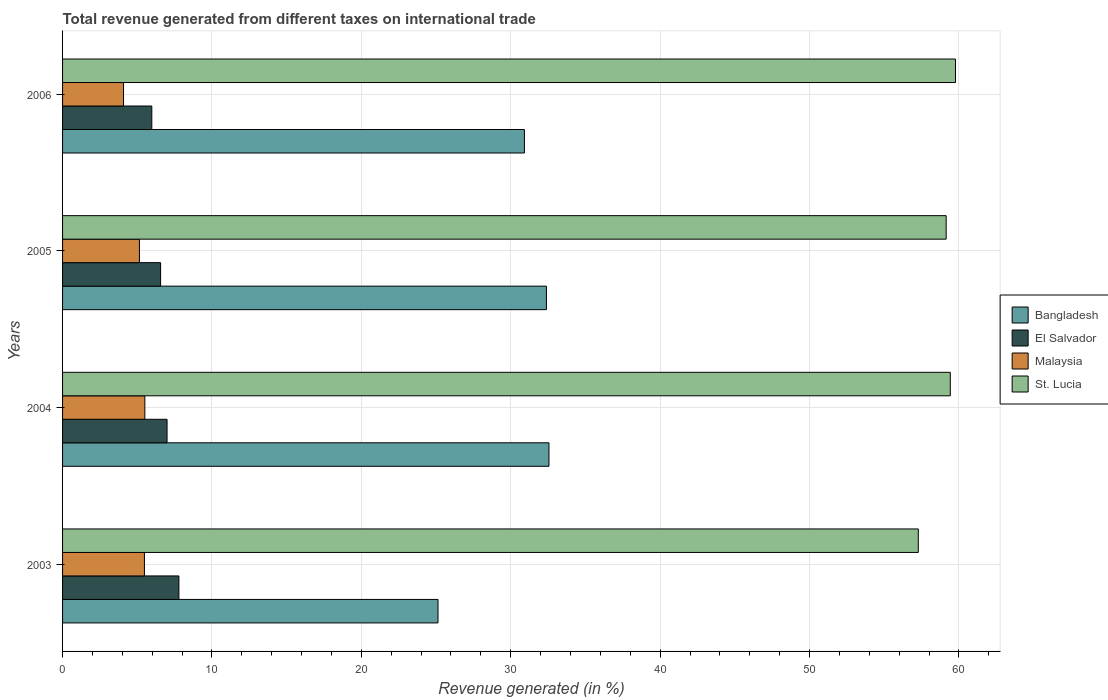How many different coloured bars are there?
Keep it short and to the point. 4. Are the number of bars per tick equal to the number of legend labels?
Offer a terse response. Yes. How many bars are there on the 2nd tick from the bottom?
Keep it short and to the point. 4. What is the label of the 2nd group of bars from the top?
Provide a succinct answer. 2005. What is the total revenue generated in El Salvador in 2005?
Offer a very short reply. 6.56. Across all years, what is the maximum total revenue generated in St. Lucia?
Your answer should be compact. 59.77. Across all years, what is the minimum total revenue generated in St. Lucia?
Offer a terse response. 57.28. In which year was the total revenue generated in El Salvador minimum?
Your answer should be compact. 2006. What is the total total revenue generated in El Salvador in the graph?
Provide a succinct answer. 27.32. What is the difference between the total revenue generated in Malaysia in 2004 and that in 2005?
Keep it short and to the point. 0.36. What is the difference between the total revenue generated in St. Lucia in 2004 and the total revenue generated in El Salvador in 2005?
Your answer should be compact. 52.86. What is the average total revenue generated in St. Lucia per year?
Provide a succinct answer. 58.9. In the year 2006, what is the difference between the total revenue generated in Malaysia and total revenue generated in Bangladesh?
Your answer should be compact. -26.84. In how many years, is the total revenue generated in Malaysia greater than 8 %?
Your response must be concise. 0. What is the ratio of the total revenue generated in El Salvador in 2004 to that in 2005?
Make the answer very short. 1.07. What is the difference between the highest and the second highest total revenue generated in Bangladesh?
Provide a succinct answer. 0.17. What is the difference between the highest and the lowest total revenue generated in Malaysia?
Keep it short and to the point. 1.43. In how many years, is the total revenue generated in Bangladesh greater than the average total revenue generated in Bangladesh taken over all years?
Ensure brevity in your answer.  3. What does the 1st bar from the top in 2005 represents?
Make the answer very short. St. Lucia. What does the 3rd bar from the bottom in 2003 represents?
Offer a terse response. Malaysia. How many bars are there?
Your answer should be compact. 16. Does the graph contain grids?
Keep it short and to the point. Yes. How many legend labels are there?
Your answer should be very brief. 4. How are the legend labels stacked?
Offer a very short reply. Vertical. What is the title of the graph?
Provide a short and direct response. Total revenue generated from different taxes on international trade. What is the label or title of the X-axis?
Give a very brief answer. Revenue generated (in %). What is the Revenue generated (in %) of Bangladesh in 2003?
Keep it short and to the point. 25.13. What is the Revenue generated (in %) in El Salvador in 2003?
Your response must be concise. 7.79. What is the Revenue generated (in %) of Malaysia in 2003?
Your response must be concise. 5.48. What is the Revenue generated (in %) of St. Lucia in 2003?
Offer a very short reply. 57.28. What is the Revenue generated (in %) in Bangladesh in 2004?
Your answer should be very brief. 32.56. What is the Revenue generated (in %) in El Salvador in 2004?
Offer a terse response. 6.99. What is the Revenue generated (in %) in Malaysia in 2004?
Offer a terse response. 5.51. What is the Revenue generated (in %) in St. Lucia in 2004?
Keep it short and to the point. 59.42. What is the Revenue generated (in %) in Bangladesh in 2005?
Give a very brief answer. 32.39. What is the Revenue generated (in %) in El Salvador in 2005?
Offer a very short reply. 6.56. What is the Revenue generated (in %) in Malaysia in 2005?
Offer a terse response. 5.15. What is the Revenue generated (in %) of St. Lucia in 2005?
Provide a succinct answer. 59.15. What is the Revenue generated (in %) in Bangladesh in 2006?
Offer a terse response. 30.92. What is the Revenue generated (in %) in El Salvador in 2006?
Make the answer very short. 5.97. What is the Revenue generated (in %) of Malaysia in 2006?
Offer a terse response. 4.08. What is the Revenue generated (in %) of St. Lucia in 2006?
Ensure brevity in your answer.  59.77. Across all years, what is the maximum Revenue generated (in %) in Bangladesh?
Your response must be concise. 32.56. Across all years, what is the maximum Revenue generated (in %) of El Salvador?
Ensure brevity in your answer.  7.79. Across all years, what is the maximum Revenue generated (in %) of Malaysia?
Ensure brevity in your answer.  5.51. Across all years, what is the maximum Revenue generated (in %) of St. Lucia?
Make the answer very short. 59.77. Across all years, what is the minimum Revenue generated (in %) in Bangladesh?
Your answer should be compact. 25.13. Across all years, what is the minimum Revenue generated (in %) in El Salvador?
Provide a succinct answer. 5.97. Across all years, what is the minimum Revenue generated (in %) in Malaysia?
Offer a very short reply. 4.08. Across all years, what is the minimum Revenue generated (in %) of St. Lucia?
Provide a short and direct response. 57.28. What is the total Revenue generated (in %) in Bangladesh in the graph?
Your response must be concise. 120.99. What is the total Revenue generated (in %) of El Salvador in the graph?
Ensure brevity in your answer.  27.32. What is the total Revenue generated (in %) in Malaysia in the graph?
Offer a terse response. 20.21. What is the total Revenue generated (in %) in St. Lucia in the graph?
Provide a succinct answer. 235.62. What is the difference between the Revenue generated (in %) of Bangladesh in 2003 and that in 2004?
Your response must be concise. -7.43. What is the difference between the Revenue generated (in %) in El Salvador in 2003 and that in 2004?
Your response must be concise. 0.79. What is the difference between the Revenue generated (in %) of Malaysia in 2003 and that in 2004?
Keep it short and to the point. -0.03. What is the difference between the Revenue generated (in %) in St. Lucia in 2003 and that in 2004?
Ensure brevity in your answer.  -2.14. What is the difference between the Revenue generated (in %) in Bangladesh in 2003 and that in 2005?
Offer a terse response. -7.26. What is the difference between the Revenue generated (in %) of El Salvador in 2003 and that in 2005?
Offer a very short reply. 1.23. What is the difference between the Revenue generated (in %) in Malaysia in 2003 and that in 2005?
Offer a very short reply. 0.33. What is the difference between the Revenue generated (in %) of St. Lucia in 2003 and that in 2005?
Provide a short and direct response. -1.87. What is the difference between the Revenue generated (in %) of Bangladesh in 2003 and that in 2006?
Make the answer very short. -5.78. What is the difference between the Revenue generated (in %) of El Salvador in 2003 and that in 2006?
Ensure brevity in your answer.  1.81. What is the difference between the Revenue generated (in %) of Malaysia in 2003 and that in 2006?
Offer a terse response. 1.4. What is the difference between the Revenue generated (in %) in St. Lucia in 2003 and that in 2006?
Provide a succinct answer. -2.49. What is the difference between the Revenue generated (in %) of Bangladesh in 2004 and that in 2005?
Make the answer very short. 0.17. What is the difference between the Revenue generated (in %) in El Salvador in 2004 and that in 2005?
Ensure brevity in your answer.  0.43. What is the difference between the Revenue generated (in %) in Malaysia in 2004 and that in 2005?
Give a very brief answer. 0.36. What is the difference between the Revenue generated (in %) of St. Lucia in 2004 and that in 2005?
Offer a terse response. 0.28. What is the difference between the Revenue generated (in %) of Bangladesh in 2004 and that in 2006?
Your answer should be very brief. 1.64. What is the difference between the Revenue generated (in %) in El Salvador in 2004 and that in 2006?
Provide a short and direct response. 1.02. What is the difference between the Revenue generated (in %) in Malaysia in 2004 and that in 2006?
Your response must be concise. 1.43. What is the difference between the Revenue generated (in %) in St. Lucia in 2004 and that in 2006?
Ensure brevity in your answer.  -0.35. What is the difference between the Revenue generated (in %) of Bangladesh in 2005 and that in 2006?
Your response must be concise. 1.47. What is the difference between the Revenue generated (in %) in El Salvador in 2005 and that in 2006?
Keep it short and to the point. 0.59. What is the difference between the Revenue generated (in %) in Malaysia in 2005 and that in 2006?
Ensure brevity in your answer.  1.07. What is the difference between the Revenue generated (in %) of St. Lucia in 2005 and that in 2006?
Keep it short and to the point. -0.62. What is the difference between the Revenue generated (in %) in Bangladesh in 2003 and the Revenue generated (in %) in El Salvador in 2004?
Offer a terse response. 18.14. What is the difference between the Revenue generated (in %) in Bangladesh in 2003 and the Revenue generated (in %) in Malaysia in 2004?
Ensure brevity in your answer.  19.62. What is the difference between the Revenue generated (in %) of Bangladesh in 2003 and the Revenue generated (in %) of St. Lucia in 2004?
Provide a succinct answer. -34.29. What is the difference between the Revenue generated (in %) in El Salvador in 2003 and the Revenue generated (in %) in Malaysia in 2004?
Keep it short and to the point. 2.28. What is the difference between the Revenue generated (in %) of El Salvador in 2003 and the Revenue generated (in %) of St. Lucia in 2004?
Your answer should be very brief. -51.64. What is the difference between the Revenue generated (in %) of Malaysia in 2003 and the Revenue generated (in %) of St. Lucia in 2004?
Provide a short and direct response. -53.94. What is the difference between the Revenue generated (in %) in Bangladesh in 2003 and the Revenue generated (in %) in El Salvador in 2005?
Offer a terse response. 18.57. What is the difference between the Revenue generated (in %) in Bangladesh in 2003 and the Revenue generated (in %) in Malaysia in 2005?
Keep it short and to the point. 19.98. What is the difference between the Revenue generated (in %) in Bangladesh in 2003 and the Revenue generated (in %) in St. Lucia in 2005?
Keep it short and to the point. -34.02. What is the difference between the Revenue generated (in %) of El Salvador in 2003 and the Revenue generated (in %) of Malaysia in 2005?
Your answer should be compact. 2.64. What is the difference between the Revenue generated (in %) in El Salvador in 2003 and the Revenue generated (in %) in St. Lucia in 2005?
Keep it short and to the point. -51.36. What is the difference between the Revenue generated (in %) in Malaysia in 2003 and the Revenue generated (in %) in St. Lucia in 2005?
Provide a succinct answer. -53.67. What is the difference between the Revenue generated (in %) in Bangladesh in 2003 and the Revenue generated (in %) in El Salvador in 2006?
Make the answer very short. 19.16. What is the difference between the Revenue generated (in %) in Bangladesh in 2003 and the Revenue generated (in %) in Malaysia in 2006?
Make the answer very short. 21.05. What is the difference between the Revenue generated (in %) of Bangladesh in 2003 and the Revenue generated (in %) of St. Lucia in 2006?
Keep it short and to the point. -34.64. What is the difference between the Revenue generated (in %) of El Salvador in 2003 and the Revenue generated (in %) of Malaysia in 2006?
Your answer should be compact. 3.71. What is the difference between the Revenue generated (in %) in El Salvador in 2003 and the Revenue generated (in %) in St. Lucia in 2006?
Ensure brevity in your answer.  -51.98. What is the difference between the Revenue generated (in %) in Malaysia in 2003 and the Revenue generated (in %) in St. Lucia in 2006?
Offer a terse response. -54.29. What is the difference between the Revenue generated (in %) of Bangladesh in 2004 and the Revenue generated (in %) of El Salvador in 2005?
Your answer should be compact. 26. What is the difference between the Revenue generated (in %) of Bangladesh in 2004 and the Revenue generated (in %) of Malaysia in 2005?
Give a very brief answer. 27.41. What is the difference between the Revenue generated (in %) of Bangladesh in 2004 and the Revenue generated (in %) of St. Lucia in 2005?
Ensure brevity in your answer.  -26.59. What is the difference between the Revenue generated (in %) in El Salvador in 2004 and the Revenue generated (in %) in Malaysia in 2005?
Your answer should be very brief. 1.85. What is the difference between the Revenue generated (in %) in El Salvador in 2004 and the Revenue generated (in %) in St. Lucia in 2005?
Provide a short and direct response. -52.15. What is the difference between the Revenue generated (in %) in Malaysia in 2004 and the Revenue generated (in %) in St. Lucia in 2005?
Offer a terse response. -53.64. What is the difference between the Revenue generated (in %) in Bangladesh in 2004 and the Revenue generated (in %) in El Salvador in 2006?
Make the answer very short. 26.58. What is the difference between the Revenue generated (in %) in Bangladesh in 2004 and the Revenue generated (in %) in Malaysia in 2006?
Offer a terse response. 28.48. What is the difference between the Revenue generated (in %) of Bangladesh in 2004 and the Revenue generated (in %) of St. Lucia in 2006?
Offer a very short reply. -27.21. What is the difference between the Revenue generated (in %) in El Salvador in 2004 and the Revenue generated (in %) in Malaysia in 2006?
Keep it short and to the point. 2.91. What is the difference between the Revenue generated (in %) in El Salvador in 2004 and the Revenue generated (in %) in St. Lucia in 2006?
Ensure brevity in your answer.  -52.78. What is the difference between the Revenue generated (in %) in Malaysia in 2004 and the Revenue generated (in %) in St. Lucia in 2006?
Make the answer very short. -54.26. What is the difference between the Revenue generated (in %) in Bangladesh in 2005 and the Revenue generated (in %) in El Salvador in 2006?
Offer a terse response. 26.41. What is the difference between the Revenue generated (in %) in Bangladesh in 2005 and the Revenue generated (in %) in Malaysia in 2006?
Provide a succinct answer. 28.31. What is the difference between the Revenue generated (in %) in Bangladesh in 2005 and the Revenue generated (in %) in St. Lucia in 2006?
Offer a terse response. -27.38. What is the difference between the Revenue generated (in %) in El Salvador in 2005 and the Revenue generated (in %) in Malaysia in 2006?
Provide a short and direct response. 2.48. What is the difference between the Revenue generated (in %) of El Salvador in 2005 and the Revenue generated (in %) of St. Lucia in 2006?
Offer a terse response. -53.21. What is the difference between the Revenue generated (in %) in Malaysia in 2005 and the Revenue generated (in %) in St. Lucia in 2006?
Make the answer very short. -54.62. What is the average Revenue generated (in %) in Bangladesh per year?
Provide a short and direct response. 30.25. What is the average Revenue generated (in %) in El Salvador per year?
Your response must be concise. 6.83. What is the average Revenue generated (in %) in Malaysia per year?
Your response must be concise. 5.05. What is the average Revenue generated (in %) in St. Lucia per year?
Provide a succinct answer. 58.9. In the year 2003, what is the difference between the Revenue generated (in %) in Bangladesh and Revenue generated (in %) in El Salvador?
Ensure brevity in your answer.  17.34. In the year 2003, what is the difference between the Revenue generated (in %) in Bangladesh and Revenue generated (in %) in Malaysia?
Provide a succinct answer. 19.65. In the year 2003, what is the difference between the Revenue generated (in %) of Bangladesh and Revenue generated (in %) of St. Lucia?
Your answer should be very brief. -32.15. In the year 2003, what is the difference between the Revenue generated (in %) of El Salvador and Revenue generated (in %) of Malaysia?
Provide a succinct answer. 2.31. In the year 2003, what is the difference between the Revenue generated (in %) of El Salvador and Revenue generated (in %) of St. Lucia?
Provide a short and direct response. -49.49. In the year 2003, what is the difference between the Revenue generated (in %) in Malaysia and Revenue generated (in %) in St. Lucia?
Offer a terse response. -51.8. In the year 2004, what is the difference between the Revenue generated (in %) of Bangladesh and Revenue generated (in %) of El Salvador?
Offer a terse response. 25.56. In the year 2004, what is the difference between the Revenue generated (in %) of Bangladesh and Revenue generated (in %) of Malaysia?
Ensure brevity in your answer.  27.05. In the year 2004, what is the difference between the Revenue generated (in %) of Bangladesh and Revenue generated (in %) of St. Lucia?
Give a very brief answer. -26.86. In the year 2004, what is the difference between the Revenue generated (in %) of El Salvador and Revenue generated (in %) of Malaysia?
Your response must be concise. 1.49. In the year 2004, what is the difference between the Revenue generated (in %) in El Salvador and Revenue generated (in %) in St. Lucia?
Offer a very short reply. -52.43. In the year 2004, what is the difference between the Revenue generated (in %) in Malaysia and Revenue generated (in %) in St. Lucia?
Offer a very short reply. -53.92. In the year 2005, what is the difference between the Revenue generated (in %) of Bangladesh and Revenue generated (in %) of El Salvador?
Ensure brevity in your answer.  25.83. In the year 2005, what is the difference between the Revenue generated (in %) in Bangladesh and Revenue generated (in %) in Malaysia?
Keep it short and to the point. 27.24. In the year 2005, what is the difference between the Revenue generated (in %) of Bangladesh and Revenue generated (in %) of St. Lucia?
Provide a succinct answer. -26.76. In the year 2005, what is the difference between the Revenue generated (in %) of El Salvador and Revenue generated (in %) of Malaysia?
Provide a succinct answer. 1.42. In the year 2005, what is the difference between the Revenue generated (in %) in El Salvador and Revenue generated (in %) in St. Lucia?
Provide a succinct answer. -52.58. In the year 2005, what is the difference between the Revenue generated (in %) in Malaysia and Revenue generated (in %) in St. Lucia?
Your response must be concise. -54. In the year 2006, what is the difference between the Revenue generated (in %) in Bangladesh and Revenue generated (in %) in El Salvador?
Your answer should be very brief. 24.94. In the year 2006, what is the difference between the Revenue generated (in %) of Bangladesh and Revenue generated (in %) of Malaysia?
Ensure brevity in your answer.  26.84. In the year 2006, what is the difference between the Revenue generated (in %) of Bangladesh and Revenue generated (in %) of St. Lucia?
Provide a short and direct response. -28.85. In the year 2006, what is the difference between the Revenue generated (in %) in El Salvador and Revenue generated (in %) in Malaysia?
Offer a terse response. 1.89. In the year 2006, what is the difference between the Revenue generated (in %) in El Salvador and Revenue generated (in %) in St. Lucia?
Ensure brevity in your answer.  -53.8. In the year 2006, what is the difference between the Revenue generated (in %) of Malaysia and Revenue generated (in %) of St. Lucia?
Ensure brevity in your answer.  -55.69. What is the ratio of the Revenue generated (in %) in Bangladesh in 2003 to that in 2004?
Keep it short and to the point. 0.77. What is the ratio of the Revenue generated (in %) of El Salvador in 2003 to that in 2004?
Your response must be concise. 1.11. What is the ratio of the Revenue generated (in %) in St. Lucia in 2003 to that in 2004?
Offer a very short reply. 0.96. What is the ratio of the Revenue generated (in %) in Bangladesh in 2003 to that in 2005?
Ensure brevity in your answer.  0.78. What is the ratio of the Revenue generated (in %) of El Salvador in 2003 to that in 2005?
Your answer should be compact. 1.19. What is the ratio of the Revenue generated (in %) of Malaysia in 2003 to that in 2005?
Your response must be concise. 1.06. What is the ratio of the Revenue generated (in %) in St. Lucia in 2003 to that in 2005?
Ensure brevity in your answer.  0.97. What is the ratio of the Revenue generated (in %) of Bangladesh in 2003 to that in 2006?
Provide a succinct answer. 0.81. What is the ratio of the Revenue generated (in %) in El Salvador in 2003 to that in 2006?
Give a very brief answer. 1.3. What is the ratio of the Revenue generated (in %) in Malaysia in 2003 to that in 2006?
Offer a terse response. 1.34. What is the ratio of the Revenue generated (in %) of St. Lucia in 2003 to that in 2006?
Offer a terse response. 0.96. What is the ratio of the Revenue generated (in %) of Bangladesh in 2004 to that in 2005?
Give a very brief answer. 1.01. What is the ratio of the Revenue generated (in %) of El Salvador in 2004 to that in 2005?
Offer a very short reply. 1.07. What is the ratio of the Revenue generated (in %) of Malaysia in 2004 to that in 2005?
Offer a very short reply. 1.07. What is the ratio of the Revenue generated (in %) of St. Lucia in 2004 to that in 2005?
Your answer should be compact. 1. What is the ratio of the Revenue generated (in %) in Bangladesh in 2004 to that in 2006?
Your answer should be compact. 1.05. What is the ratio of the Revenue generated (in %) in El Salvador in 2004 to that in 2006?
Your answer should be compact. 1.17. What is the ratio of the Revenue generated (in %) of Malaysia in 2004 to that in 2006?
Your response must be concise. 1.35. What is the ratio of the Revenue generated (in %) of St. Lucia in 2004 to that in 2006?
Offer a very short reply. 0.99. What is the ratio of the Revenue generated (in %) in Bangladesh in 2005 to that in 2006?
Your answer should be very brief. 1.05. What is the ratio of the Revenue generated (in %) of El Salvador in 2005 to that in 2006?
Give a very brief answer. 1.1. What is the ratio of the Revenue generated (in %) in Malaysia in 2005 to that in 2006?
Provide a succinct answer. 1.26. What is the difference between the highest and the second highest Revenue generated (in %) of Bangladesh?
Your response must be concise. 0.17. What is the difference between the highest and the second highest Revenue generated (in %) of El Salvador?
Your answer should be compact. 0.79. What is the difference between the highest and the second highest Revenue generated (in %) of Malaysia?
Keep it short and to the point. 0.03. What is the difference between the highest and the second highest Revenue generated (in %) in St. Lucia?
Your response must be concise. 0.35. What is the difference between the highest and the lowest Revenue generated (in %) of Bangladesh?
Make the answer very short. 7.43. What is the difference between the highest and the lowest Revenue generated (in %) of El Salvador?
Your answer should be very brief. 1.81. What is the difference between the highest and the lowest Revenue generated (in %) of Malaysia?
Your answer should be compact. 1.43. What is the difference between the highest and the lowest Revenue generated (in %) in St. Lucia?
Your response must be concise. 2.49. 